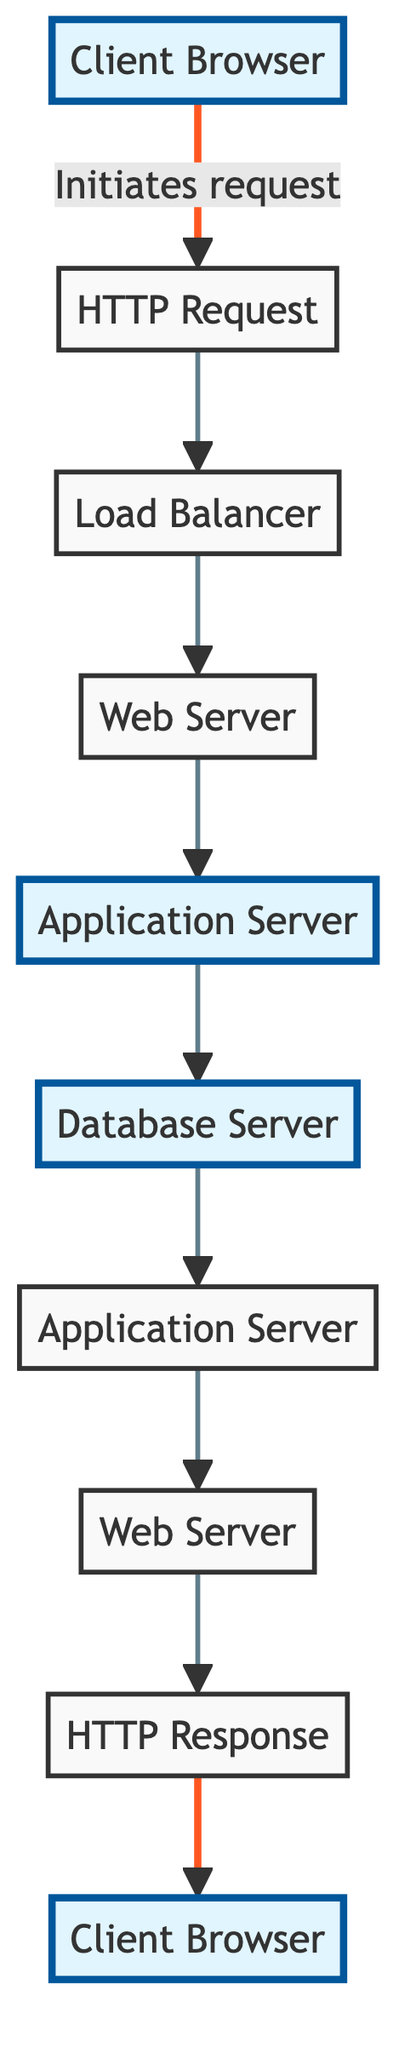What is the starting point of the flow chart? The flow chart begins with the "Client Browser" at the bottom, which initiates the request for dynamic content.
Answer: Client Browser How many servers are involved in the request-response cycle? The diagram includes three server types: the Web Server, Application Server, and Database Server. Counting the instances, there are four: one Web Server, two Application Servers, and one Database Server.
Answer: Four Which component immediately receives the HTTP request? The "Load Balancer" is the component that directly receives the HTTP request after it has been sent from the Client Browser.
Answer: Load Balancer What does the Application Server do after retrieving data from the Database Server? The Application Server processes the data it received from the Database Server and generates dynamic web content.
Answer: Generates dynamic web content How is the HTTP response transmitted back to the Client Browser? The HTTP response is transmitted back through the Web Server, which prepares it after receiving dynamic content from the Application Server, then sends it back to the Client Browser.
Answer: Through the Web Server Which step occurs directly after the HTTP Request? The step that follows the HTTP Request is the Load Balancer, which distributes incoming requests.
Answer: Load Balancer What is the role of the Load Balancer in this cycle? The Load Balancer's role is to distribute incoming HTTP requests across multiple web servers to ensure system reliability and availability.
Answer: Distributes incoming HTTP requests Which element is highlighted most prominently in the diagram? The two most prominent highlighted elements in the flow chart are the Application Server and the Client Browser.
Answer: Application Server What is the final component that handles the transmitted response? The final component that handles the transmitted response is the Client Browser, which renders the dynamic web content for the user.
Answer: Client Browser 